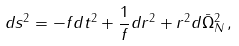Convert formula to latex. <formula><loc_0><loc_0><loc_500><loc_500>d s ^ { 2 } = - f d t ^ { 2 } + \frac { 1 } { f } d r ^ { 2 } + r ^ { 2 } d \bar { \Omega } ^ { 2 } _ { N } \, ,</formula> 